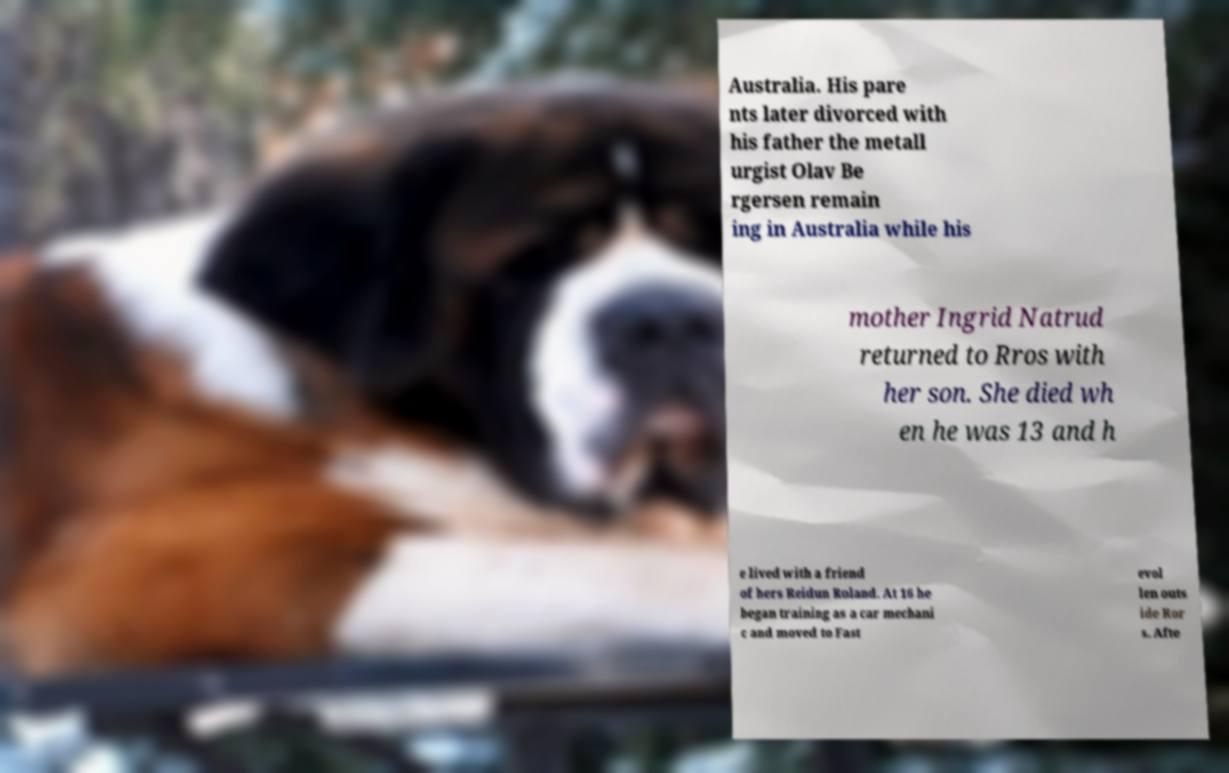What messages or text are displayed in this image? I need them in a readable, typed format. Australia. His pare nts later divorced with his father the metall urgist Olav Be rgersen remain ing in Australia while his mother Ingrid Natrud returned to Rros with her son. She died wh en he was 13 and h e lived with a friend of hers Reidun Roland. At 16 he began training as a car mechani c and moved to Fast evol len outs ide Ror s. Afte 